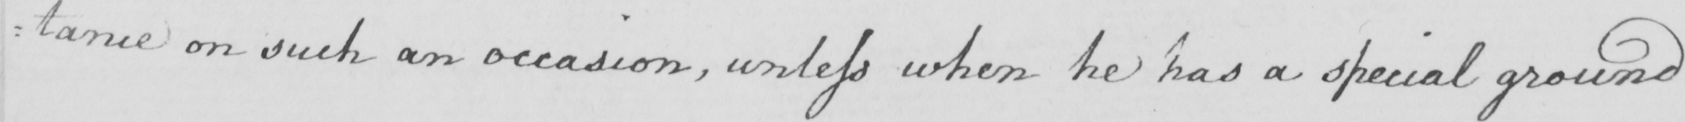What is written in this line of handwriting? : tance on such an occasion , unless when he has a special ground 